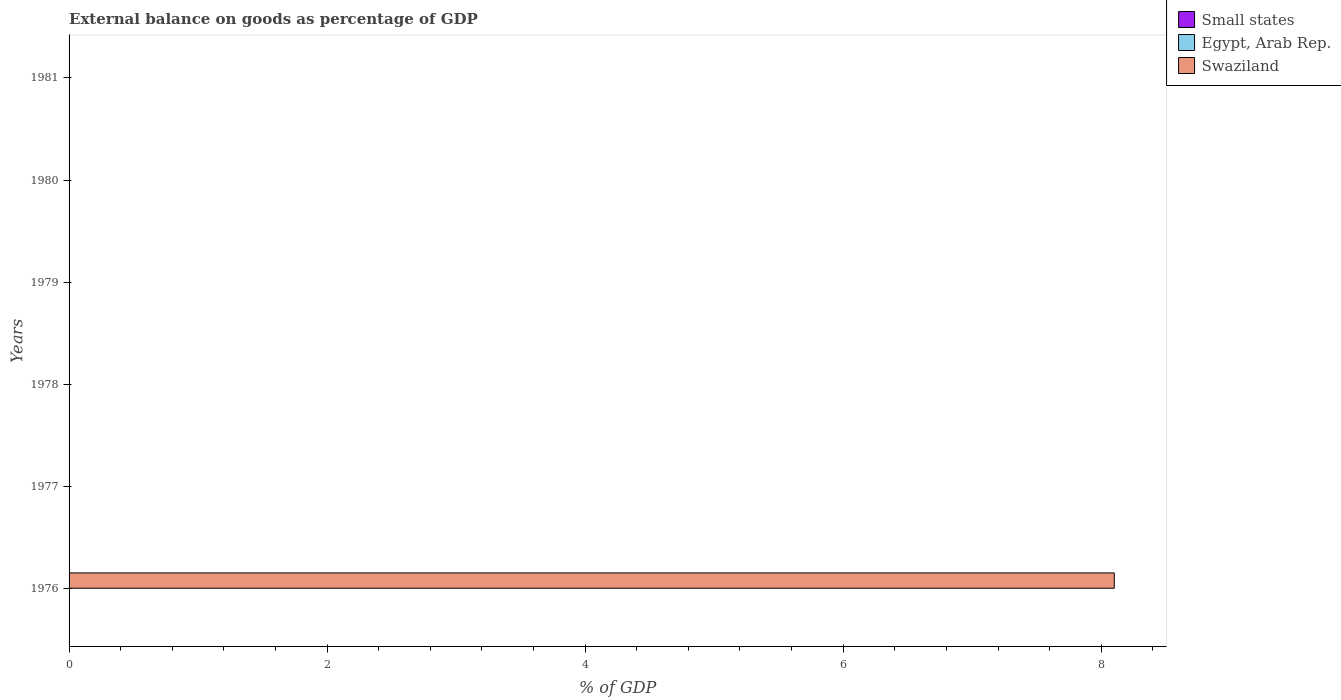How many different coloured bars are there?
Provide a short and direct response. 1. Are the number of bars on each tick of the Y-axis equal?
Provide a succinct answer. No. How many bars are there on the 4th tick from the bottom?
Offer a terse response. 0. What is the label of the 4th group of bars from the top?
Give a very brief answer. 1978. What is the external balance on goods as percentage of GDP in Egypt, Arab Rep. in 1981?
Make the answer very short. 0. Across all years, what is the maximum external balance on goods as percentage of GDP in Swaziland?
Offer a very short reply. 8.1. Across all years, what is the minimum external balance on goods as percentage of GDP in Small states?
Provide a short and direct response. 0. In which year was the external balance on goods as percentage of GDP in Swaziland maximum?
Give a very brief answer. 1976. What is the total external balance on goods as percentage of GDP in Small states in the graph?
Your response must be concise. 0. What is the difference between the external balance on goods as percentage of GDP in Swaziland in 1977 and the external balance on goods as percentage of GDP in Small states in 1976?
Your answer should be compact. 0. In how many years, is the external balance on goods as percentage of GDP in Egypt, Arab Rep. greater than 6.8 %?
Make the answer very short. 0. What is the difference between the highest and the lowest external balance on goods as percentage of GDP in Swaziland?
Keep it short and to the point. 8.1. In how many years, is the external balance on goods as percentage of GDP in Small states greater than the average external balance on goods as percentage of GDP in Small states taken over all years?
Give a very brief answer. 0. How many years are there in the graph?
Ensure brevity in your answer.  6. Are the values on the major ticks of X-axis written in scientific E-notation?
Offer a terse response. No. Does the graph contain grids?
Make the answer very short. No. Where does the legend appear in the graph?
Offer a terse response. Top right. How are the legend labels stacked?
Make the answer very short. Vertical. What is the title of the graph?
Give a very brief answer. External balance on goods as percentage of GDP. Does "Mauritania" appear as one of the legend labels in the graph?
Your answer should be compact. No. What is the label or title of the X-axis?
Offer a terse response. % of GDP. What is the % of GDP of Small states in 1976?
Provide a succinct answer. 0. What is the % of GDP of Egypt, Arab Rep. in 1976?
Ensure brevity in your answer.  0. What is the % of GDP of Swaziland in 1976?
Offer a very short reply. 8.1. What is the % of GDP of Swaziland in 1977?
Make the answer very short. 0. What is the % of GDP in Small states in 1978?
Keep it short and to the point. 0. What is the % of GDP in Egypt, Arab Rep. in 1978?
Ensure brevity in your answer.  0. What is the % of GDP of Egypt, Arab Rep. in 1979?
Give a very brief answer. 0. What is the % of GDP of Small states in 1980?
Provide a short and direct response. 0. What is the % of GDP of Egypt, Arab Rep. in 1980?
Your answer should be compact. 0. What is the % of GDP of Swaziland in 1980?
Ensure brevity in your answer.  0. What is the % of GDP of Small states in 1981?
Offer a terse response. 0. What is the % of GDP in Swaziland in 1981?
Provide a short and direct response. 0. Across all years, what is the maximum % of GDP of Swaziland?
Provide a succinct answer. 8.1. Across all years, what is the minimum % of GDP of Swaziland?
Offer a terse response. 0. What is the total % of GDP in Small states in the graph?
Provide a short and direct response. 0. What is the total % of GDP in Swaziland in the graph?
Provide a succinct answer. 8.1. What is the average % of GDP of Swaziland per year?
Your response must be concise. 1.35. What is the difference between the highest and the lowest % of GDP in Swaziland?
Your answer should be compact. 8.1. 